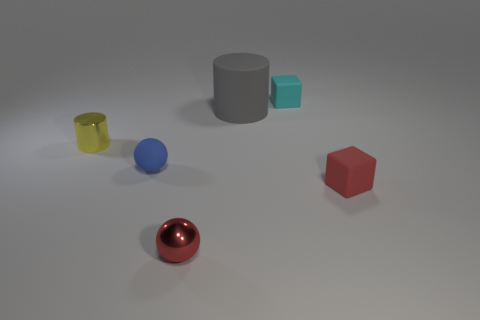What is the shape of the tiny rubber thing behind the yellow object?
Your answer should be very brief. Cube. There is a small sphere in front of the small block that is right of the cyan rubber cube; what is its color?
Ensure brevity in your answer.  Red. How many things are either small red things in front of the tiny red cube or brown objects?
Keep it short and to the point. 1. Does the cyan object have the same size as the ball that is behind the red matte block?
Provide a short and direct response. Yes. What number of small objects are either green rubber spheres or blue matte things?
Keep it short and to the point. 1. There is a red matte object; what shape is it?
Keep it short and to the point. Cube. What is the size of the thing that is the same color as the small metallic sphere?
Provide a succinct answer. Small. Are there any red blocks made of the same material as the tiny red ball?
Keep it short and to the point. No. Is the number of large brown metal blocks greater than the number of big rubber objects?
Offer a terse response. No. Is the material of the red ball the same as the blue ball?
Provide a succinct answer. No. 